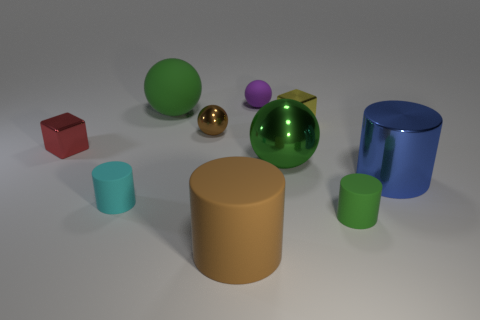Subtract all brown spheres. How many spheres are left? 3 Subtract 1 cylinders. How many cylinders are left? 3 Subtract all purple cylinders. Subtract all red blocks. How many cylinders are left? 4 Subtract all blocks. How many objects are left? 8 Subtract all metallic things. Subtract all tiny matte things. How many objects are left? 2 Add 1 cyan things. How many cyan things are left? 2 Add 2 brown objects. How many brown objects exist? 4 Subtract 0 cyan balls. How many objects are left? 10 